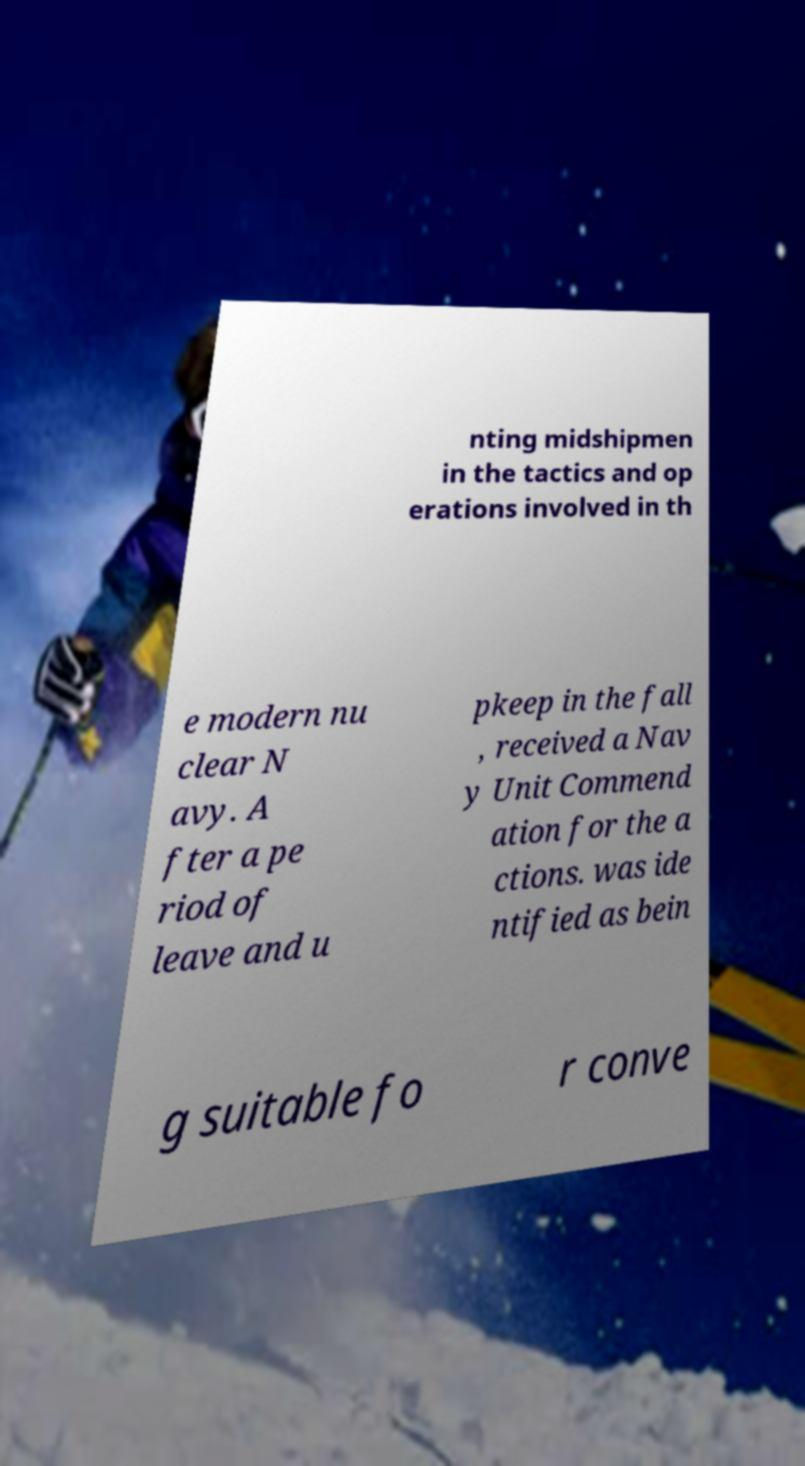Please identify and transcribe the text found in this image. nting midshipmen in the tactics and op erations involved in th e modern nu clear N avy. A fter a pe riod of leave and u pkeep in the fall , received a Nav y Unit Commend ation for the a ctions. was ide ntified as bein g suitable fo r conve 